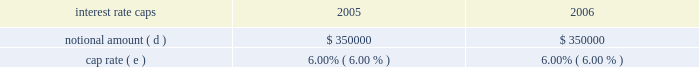Aggregate notional amounts associated with interest rate caps in place as of december 31 , 2004 and interest rate detail by contractual maturity dates ( in thousands , except percentages ) .
( a ) as of december 31 , 2005 , variable rate debt consists of the new american tower and spectrasite credit facilities ( $ 1493.0 million ) that were refinanced on october 27 , 2005 , which are included above based on their october 27 , 2010 maturity dates .
As of december 31 , 2005 , fixed rate debt consists of : the 2.25% ( 2.25 % ) convertible notes due 2009 ( 2.25% ( 2.25 % ) notes ) ( $ 0.1 million ) ; the 7.125% ( 7.125 % ) notes ( $ 500.0 million principal amount due at maturity ; the balance as of december 31 , 2005 is $ 501.9 million ) ; the 5.0% ( 5.0 % ) notes ( $ 275.7 million ) ; the 3.25% ( 3.25 % ) notes ( $ 152.9 million ) ; the 7.50% ( 7.50 % ) notes ( $ 225.0 million ) ; the ati 7.25% ( 7.25 % ) notes ( $ 400.0 million ) ; the ati 12.25% ( 12.25 % ) notes ( $ 227.7 million principal amount due at maturity ; the balance as of december 31 , 2005 is $ 160.3 million accreted value , net of the allocated fair value of the related warrants of $ 7.2 million ) ; the 3.00% ( 3.00 % ) notes ( $ 345.0 million principal amount due at maturity ; the balance as of december 31 , 2005 is $ 344.4 million accreted value ) and other debt of $ 60.4 million .
Interest on our credit facilities is payable in accordance with the applicable london interbank offering rate ( libor ) agreement or quarterly and accrues at our option either at libor plus margin ( as defined ) or the base rate plus margin ( as defined ) .
The weighted average interest rate in effect at december 31 , 2005 for our credit facilities was 4.71% ( 4.71 % ) .
For the year ended december 31 , 2005 , the weighted average interest rate under our credit facilities was 5.03% ( 5.03 % ) .
As of december 31 , 2004 , variable rate debt consists of our previous credit facility ( $ 698.0 million ) and fixed rate debt consists of : the 2.25% ( 2.25 % ) notes ( $ 0.1 million ) ; the 7.125% ( 7.125 % ) notes ( $ 500.0 million principal amount due at maturity ; the balance as of december 31 , 2004 is $ 501.9 million ) ; the 5.0% ( 5.0 % ) notes ( $ 275.7 million ) ; the 3.25% ( 3.25 % ) notes ( $ 210.0 million ) ; the 7.50% ( 7.50 % ) notes ( $ 225.0 million ) ; the ati 7.25% ( 7.25 % ) notes ( $ 400.0 million ) ; the ati 12.25% ( 12.25 % ) notes ( $ 498.3 million principal amount due at maturity ; the balance as of december 31 , 2004 is $ 303.8 million accreted value , net of the allocated fair value of the related warrants of $ 21.6 million ) ; the 9 3 20448% ( 20448 % ) notes ( $ 274.9 million ) ; the 3.00% ( 3.00 % ) notes ( $ 345.0 million principal amount due at maturity ; the balance as of december 31 , 2004 is $ 344.3 million accreted value ) and other debt of $ 60.0 million .
Interest on the credit facility was payable in accordance with the applicable london interbank offering rate ( libor ) agreement or quarterly and accrues at our option either at libor plus margin ( as defined ) or the base rate plus margin ( as defined ) .
The weighted average interest rate in effect at december 31 , 2004 for the credit facility was 4.35% ( 4.35 % ) .
For the year ended december 31 , 2004 , the weighted average interest rate under the credit facility was 3.81% ( 3.81 % ) .
( b ) includes notional amount of $ 175000 that expires in february 2006 .
( c ) includes notional amount of $ 25000 that expires in september 2007 .
( d ) includes notional amounts of $ 250000 and $ 100000 that expire in june and july 2006 , respectively .
( e ) represents the weighted-average fixed rate or range of interest based on contractual notional amount as a percentage of total notional amounts in a given year .
( f ) includes notional amounts of $ 75000 , $ 75000 and $ 150000 that expire in december 2009 .
( g ) includes notional amounts of $ 100000 , $ 50000 , $ 50000 , $ 50000 and $ 50000 that expire in october 2010 .
( h ) includes notional amounts of $ 50000 and $ 50000 that expire in october 2010 .
( i ) includes notional amount of $ 50000 that expires in october 2010 .
Our foreign operations include rental and management segment divisions in mexico and brazil .
The remeasurement gain for the year ended december 31 , 2005 was $ 396000 , and the remeasurement losses for the years ended december 31 , 2004 , and 2003 approximated $ 146000 , and $ 1142000 , respectively .
Changes in interest rates can cause interest charges to fluctuate on our variable rate debt , comprised of $ 1493.0 million under our credit facilities as of december 31 , 2005 .
A 10% ( 10 % ) increase , or approximately 47 basis points , in current interest rates would have caused an additional pre-tax charge our net loss and an increase in our cash outflows of $ 7.0 million for the year ended december 31 , 2005 .
Item 8 .
Financial statements and supplementary data see item 15 ( a ) .
Item 9 .
Changes in and disagreements with accountants on accounting and financial disclosure .
What was the ratio of the re-measurement gain from 2005 to 2004? 
Rationale: the re-measurement gain in 2005 was 2.7 times the re-measurement gain in 2004
Computations: (396000 / 146000)
Answer: 2.71233. 